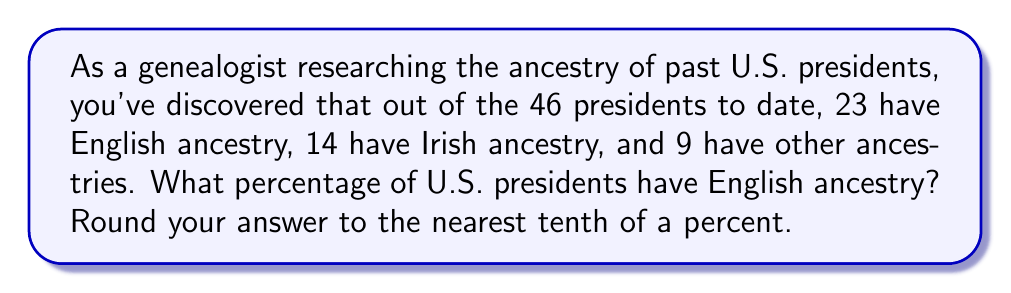Provide a solution to this math problem. To solve this problem, we need to follow these steps:

1. Identify the total number of presidents: 46

2. Identify the number of presidents with English ancestry: 23

3. Calculate the fraction of presidents with English ancestry:
   $\frac{23}{46}$

4. Convert the fraction to a percentage:
   $$\text{Percentage} = \frac{\text{Number of presidents with English ancestry}}{\text{Total number of presidents}} \times 100\%$$
   $$= \frac{23}{46} \times 100\%$$
   $$= 0.5 \times 100\%$$
   $$= 50\%$$

5. Since the question asks to round to the nearest tenth of a percent, 50% is already in this form.

Therefore, the percentage of U.S. presidents with English ancestry is 50.0%.
Answer: 50.0% 